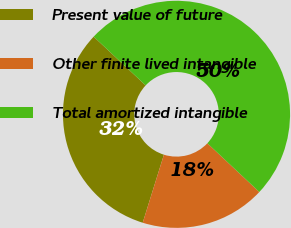<chart> <loc_0><loc_0><loc_500><loc_500><pie_chart><fcel>Present value of future<fcel>Other finite lived intangible<fcel>Total amortized intangible<nl><fcel>32.18%<fcel>17.82%<fcel>50.0%<nl></chart> 